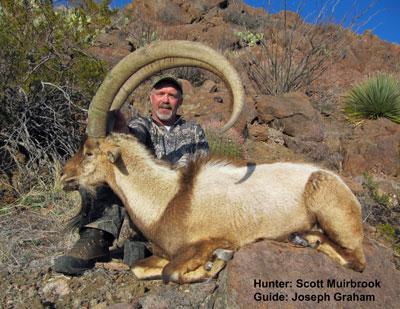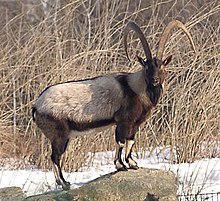The first image is the image on the left, the second image is the image on the right. For the images displayed, is the sentence "A man stands behind his hunting trophy." factually correct? Answer yes or no. Yes. The first image is the image on the left, the second image is the image on the right. Considering the images on both sides, is "The left and right image contains the same number of goats with at least one hunter holding its horns." valid? Answer yes or no. Yes. 